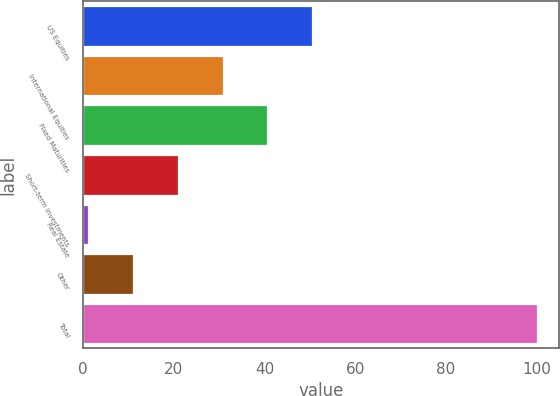Convert chart to OTSL. <chart><loc_0><loc_0><loc_500><loc_500><bar_chart><fcel>US Equities<fcel>International Equities<fcel>Fixed Maturities<fcel>Short-term Investments<fcel>Real Estate<fcel>Other<fcel>Total<nl><fcel>50.52<fcel>30.72<fcel>40.62<fcel>20.82<fcel>1.02<fcel>10.92<fcel>100<nl></chart> 